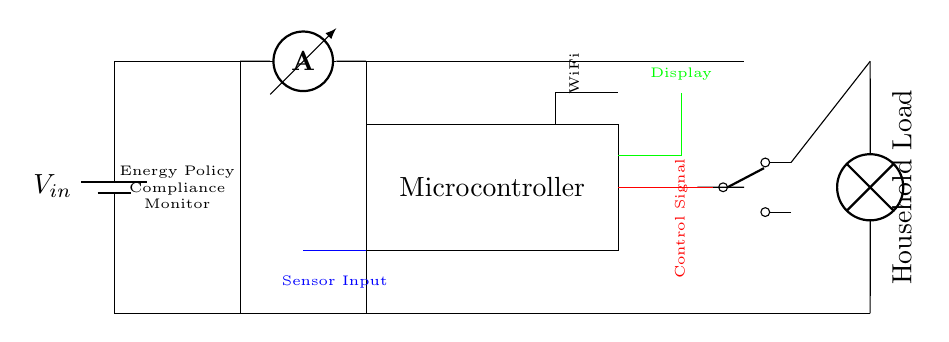What is the main component that processes energy consumption data? The Microcontroller is the key component responsible for managing and processing data related to energy consumption within the circuit. It connects various inputs and controls the output based on the readings it processes.
Answer: Microcontroller What type of sensor input is depicted in the circuit? The circuit indicates that a Sensor Input is utilized, which is meant to gather data regarding the current consumption or performance of the household's energy usage. This input informs the Microcontroller about the energy consumption levels.
Answer: Sensor Input What is the purpose of the relay in the circuit? The relay acts as a switch to control the connection between the Microcontroller and the household load. When activated by a control signal from the Microcontroller, it allows or disallows electricity to flow to the load based on the energy consumption data.
Answer: Control electricity flow What component connects to WiFi for remote monitoring? The circuit includes a WiFi module, which enables the Microcontroller to communicate energy consumption data wirelessly to a cloud service or app for remote monitoring. This enhances user control and awareness of energy usage.
Answer: WiFi module What type of load is represented in the circuit? The circuit specifies a Household Load, which signifies that the monitored device could be any electrical appliance in a home. The load's operation can be managed depending on the energy data received.
Answer: Household Load How does the energy policy monitor compliance in the circuit? The Energy Policy Compliance Monitor component is indicated in the circuit as a means to ensure that the household adheres to an energy-saving standards. It works alongside the Microcontroller to provide feedback based on the energy consumption readings against a predefined energy policy.
Answer: Energy Policy Compliance Monitor 